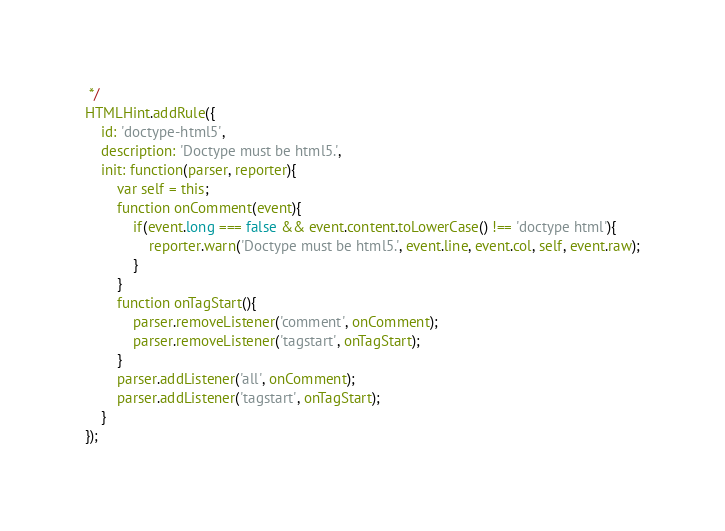<code> <loc_0><loc_0><loc_500><loc_500><_JavaScript_> */
HTMLHint.addRule({
    id: 'doctype-html5',
    description: 'Doctype must be html5.',
    init: function(parser, reporter){
        var self = this;
        function onComment(event){
            if(event.long === false && event.content.toLowerCase() !== 'doctype html'){
                reporter.warn('Doctype must be html5.', event.line, event.col, self, event.raw);
            }
        }
        function onTagStart(){
            parser.removeListener('comment', onComment);
            parser.removeListener('tagstart', onTagStart);
        }
        parser.addListener('all', onComment);
        parser.addListener('tagstart', onTagStart);
    }
});</code> 